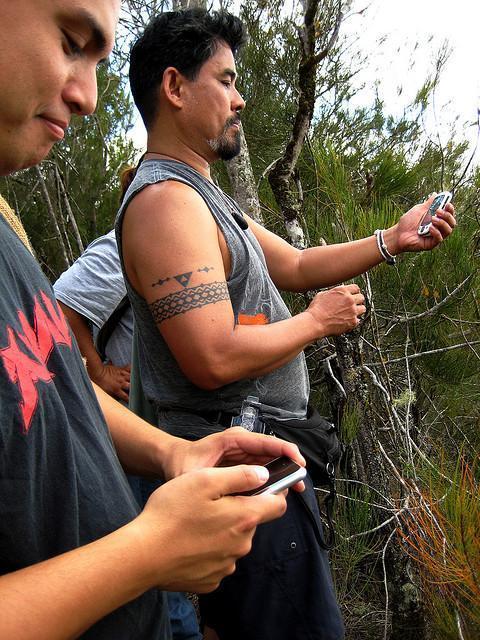How many people are there?
Give a very brief answer. 3. 